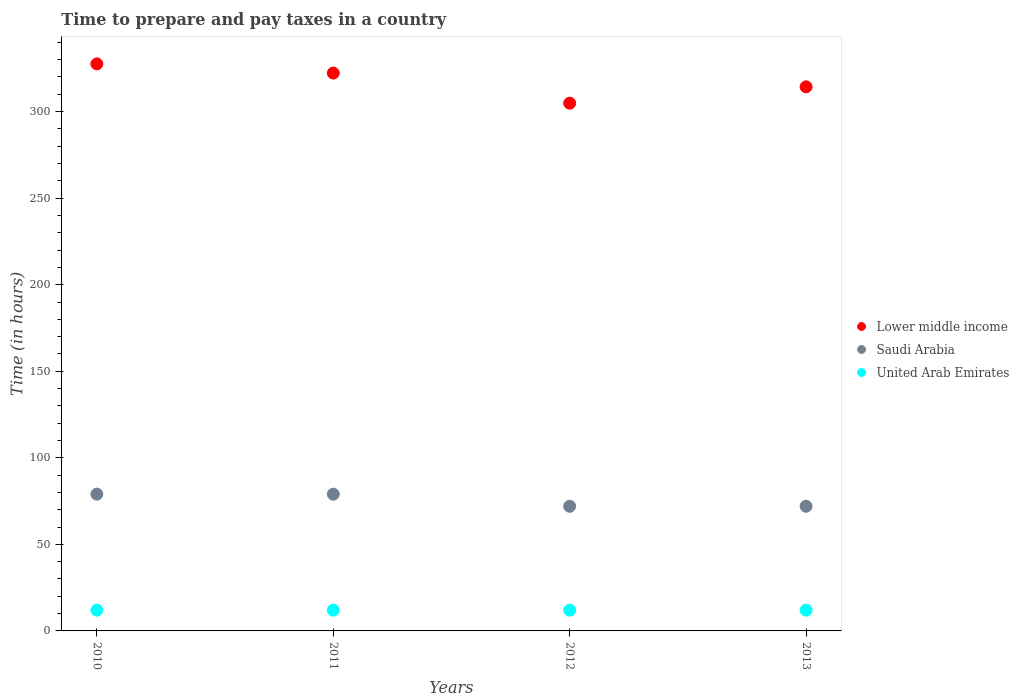What is the number of hours required to prepare and pay taxes in Lower middle income in 2012?
Keep it short and to the point. 304.86. Across all years, what is the maximum number of hours required to prepare and pay taxes in United Arab Emirates?
Provide a succinct answer. 12. Across all years, what is the minimum number of hours required to prepare and pay taxes in United Arab Emirates?
Give a very brief answer. 12. What is the total number of hours required to prepare and pay taxes in Lower middle income in the graph?
Make the answer very short. 1268.98. What is the difference between the number of hours required to prepare and pay taxes in United Arab Emirates in 2011 and that in 2013?
Your answer should be compact. 0. What is the difference between the number of hours required to prepare and pay taxes in Lower middle income in 2013 and the number of hours required to prepare and pay taxes in Saudi Arabia in 2010?
Offer a terse response. 235.31. What is the average number of hours required to prepare and pay taxes in Lower middle income per year?
Give a very brief answer. 317.24. In the year 2010, what is the difference between the number of hours required to prepare and pay taxes in Lower middle income and number of hours required to prepare and pay taxes in United Arab Emirates?
Keep it short and to the point. 315.56. In how many years, is the number of hours required to prepare and pay taxes in United Arab Emirates greater than 190 hours?
Offer a terse response. 0. Is the number of hours required to prepare and pay taxes in United Arab Emirates in 2010 less than that in 2011?
Provide a short and direct response. No. What is the difference between the highest and the second highest number of hours required to prepare and pay taxes in Lower middle income?
Offer a very short reply. 5.32. What is the difference between the highest and the lowest number of hours required to prepare and pay taxes in Saudi Arabia?
Your response must be concise. 7. In how many years, is the number of hours required to prepare and pay taxes in United Arab Emirates greater than the average number of hours required to prepare and pay taxes in United Arab Emirates taken over all years?
Make the answer very short. 0. Is the sum of the number of hours required to prepare and pay taxes in Lower middle income in 2010 and 2011 greater than the maximum number of hours required to prepare and pay taxes in United Arab Emirates across all years?
Provide a short and direct response. Yes. Is it the case that in every year, the sum of the number of hours required to prepare and pay taxes in United Arab Emirates and number of hours required to prepare and pay taxes in Lower middle income  is greater than the number of hours required to prepare and pay taxes in Saudi Arabia?
Provide a short and direct response. Yes. Does the number of hours required to prepare and pay taxes in Lower middle income monotonically increase over the years?
Offer a very short reply. No. Is the number of hours required to prepare and pay taxes in United Arab Emirates strictly greater than the number of hours required to prepare and pay taxes in Lower middle income over the years?
Offer a terse response. No. Is the number of hours required to prepare and pay taxes in Saudi Arabia strictly less than the number of hours required to prepare and pay taxes in United Arab Emirates over the years?
Your answer should be compact. No. What is the difference between two consecutive major ticks on the Y-axis?
Your response must be concise. 50. Does the graph contain grids?
Offer a terse response. No. Where does the legend appear in the graph?
Give a very brief answer. Center right. How many legend labels are there?
Provide a succinct answer. 3. How are the legend labels stacked?
Make the answer very short. Vertical. What is the title of the graph?
Provide a short and direct response. Time to prepare and pay taxes in a country. Does "Sub-Saharan Africa (developing only)" appear as one of the legend labels in the graph?
Give a very brief answer. No. What is the label or title of the Y-axis?
Offer a terse response. Time (in hours). What is the Time (in hours) of Lower middle income in 2010?
Your answer should be compact. 327.56. What is the Time (in hours) of Saudi Arabia in 2010?
Ensure brevity in your answer.  79. What is the Time (in hours) of United Arab Emirates in 2010?
Offer a terse response. 12. What is the Time (in hours) in Lower middle income in 2011?
Give a very brief answer. 322.24. What is the Time (in hours) of Saudi Arabia in 2011?
Your answer should be very brief. 79. What is the Time (in hours) of Lower middle income in 2012?
Provide a short and direct response. 304.86. What is the Time (in hours) in Lower middle income in 2013?
Make the answer very short. 314.31. Across all years, what is the maximum Time (in hours) in Lower middle income?
Provide a succinct answer. 327.56. Across all years, what is the maximum Time (in hours) of Saudi Arabia?
Make the answer very short. 79. Across all years, what is the maximum Time (in hours) of United Arab Emirates?
Ensure brevity in your answer.  12. Across all years, what is the minimum Time (in hours) of Lower middle income?
Offer a very short reply. 304.86. Across all years, what is the minimum Time (in hours) of United Arab Emirates?
Your response must be concise. 12. What is the total Time (in hours) in Lower middle income in the graph?
Give a very brief answer. 1268.98. What is the total Time (in hours) in Saudi Arabia in the graph?
Ensure brevity in your answer.  302. What is the total Time (in hours) of United Arab Emirates in the graph?
Provide a succinct answer. 48. What is the difference between the Time (in hours) in Lower middle income in 2010 and that in 2011?
Your response must be concise. 5.32. What is the difference between the Time (in hours) of Saudi Arabia in 2010 and that in 2011?
Your answer should be very brief. 0. What is the difference between the Time (in hours) in United Arab Emirates in 2010 and that in 2011?
Provide a short and direct response. 0. What is the difference between the Time (in hours) in Lower middle income in 2010 and that in 2012?
Your answer should be compact. 22.7. What is the difference between the Time (in hours) of United Arab Emirates in 2010 and that in 2012?
Ensure brevity in your answer.  0. What is the difference between the Time (in hours) of Lower middle income in 2010 and that in 2013?
Provide a succinct answer. 13.25. What is the difference between the Time (in hours) of Saudi Arabia in 2010 and that in 2013?
Offer a very short reply. 7. What is the difference between the Time (in hours) in Lower middle income in 2011 and that in 2012?
Ensure brevity in your answer.  17.39. What is the difference between the Time (in hours) in Saudi Arabia in 2011 and that in 2012?
Offer a terse response. 7. What is the difference between the Time (in hours) in United Arab Emirates in 2011 and that in 2012?
Provide a succinct answer. 0. What is the difference between the Time (in hours) in Lower middle income in 2011 and that in 2013?
Provide a short and direct response. 7.93. What is the difference between the Time (in hours) of Saudi Arabia in 2011 and that in 2013?
Your response must be concise. 7. What is the difference between the Time (in hours) of United Arab Emirates in 2011 and that in 2013?
Offer a terse response. 0. What is the difference between the Time (in hours) in Lower middle income in 2012 and that in 2013?
Provide a succinct answer. -9.45. What is the difference between the Time (in hours) in United Arab Emirates in 2012 and that in 2013?
Give a very brief answer. 0. What is the difference between the Time (in hours) of Lower middle income in 2010 and the Time (in hours) of Saudi Arabia in 2011?
Give a very brief answer. 248.56. What is the difference between the Time (in hours) in Lower middle income in 2010 and the Time (in hours) in United Arab Emirates in 2011?
Make the answer very short. 315.56. What is the difference between the Time (in hours) in Lower middle income in 2010 and the Time (in hours) in Saudi Arabia in 2012?
Offer a very short reply. 255.56. What is the difference between the Time (in hours) of Lower middle income in 2010 and the Time (in hours) of United Arab Emirates in 2012?
Keep it short and to the point. 315.56. What is the difference between the Time (in hours) in Lower middle income in 2010 and the Time (in hours) in Saudi Arabia in 2013?
Offer a terse response. 255.56. What is the difference between the Time (in hours) of Lower middle income in 2010 and the Time (in hours) of United Arab Emirates in 2013?
Offer a very short reply. 315.56. What is the difference between the Time (in hours) of Saudi Arabia in 2010 and the Time (in hours) of United Arab Emirates in 2013?
Your response must be concise. 67. What is the difference between the Time (in hours) in Lower middle income in 2011 and the Time (in hours) in Saudi Arabia in 2012?
Provide a short and direct response. 250.24. What is the difference between the Time (in hours) in Lower middle income in 2011 and the Time (in hours) in United Arab Emirates in 2012?
Your response must be concise. 310.24. What is the difference between the Time (in hours) of Lower middle income in 2011 and the Time (in hours) of Saudi Arabia in 2013?
Give a very brief answer. 250.24. What is the difference between the Time (in hours) in Lower middle income in 2011 and the Time (in hours) in United Arab Emirates in 2013?
Offer a very short reply. 310.24. What is the difference between the Time (in hours) in Saudi Arabia in 2011 and the Time (in hours) in United Arab Emirates in 2013?
Ensure brevity in your answer.  67. What is the difference between the Time (in hours) in Lower middle income in 2012 and the Time (in hours) in Saudi Arabia in 2013?
Keep it short and to the point. 232.86. What is the difference between the Time (in hours) in Lower middle income in 2012 and the Time (in hours) in United Arab Emirates in 2013?
Offer a very short reply. 292.86. What is the difference between the Time (in hours) of Saudi Arabia in 2012 and the Time (in hours) of United Arab Emirates in 2013?
Make the answer very short. 60. What is the average Time (in hours) of Lower middle income per year?
Your response must be concise. 317.24. What is the average Time (in hours) in Saudi Arabia per year?
Your response must be concise. 75.5. In the year 2010, what is the difference between the Time (in hours) of Lower middle income and Time (in hours) of Saudi Arabia?
Give a very brief answer. 248.56. In the year 2010, what is the difference between the Time (in hours) in Lower middle income and Time (in hours) in United Arab Emirates?
Your answer should be compact. 315.56. In the year 2011, what is the difference between the Time (in hours) in Lower middle income and Time (in hours) in Saudi Arabia?
Offer a terse response. 243.24. In the year 2011, what is the difference between the Time (in hours) of Lower middle income and Time (in hours) of United Arab Emirates?
Your answer should be very brief. 310.24. In the year 2012, what is the difference between the Time (in hours) in Lower middle income and Time (in hours) in Saudi Arabia?
Your response must be concise. 232.86. In the year 2012, what is the difference between the Time (in hours) in Lower middle income and Time (in hours) in United Arab Emirates?
Provide a succinct answer. 292.86. In the year 2012, what is the difference between the Time (in hours) in Saudi Arabia and Time (in hours) in United Arab Emirates?
Ensure brevity in your answer.  60. In the year 2013, what is the difference between the Time (in hours) of Lower middle income and Time (in hours) of Saudi Arabia?
Your answer should be compact. 242.31. In the year 2013, what is the difference between the Time (in hours) in Lower middle income and Time (in hours) in United Arab Emirates?
Your response must be concise. 302.31. In the year 2013, what is the difference between the Time (in hours) in Saudi Arabia and Time (in hours) in United Arab Emirates?
Your answer should be very brief. 60. What is the ratio of the Time (in hours) in Lower middle income in 2010 to that in 2011?
Provide a succinct answer. 1.02. What is the ratio of the Time (in hours) of United Arab Emirates in 2010 to that in 2011?
Give a very brief answer. 1. What is the ratio of the Time (in hours) in Lower middle income in 2010 to that in 2012?
Offer a terse response. 1.07. What is the ratio of the Time (in hours) of Saudi Arabia in 2010 to that in 2012?
Offer a terse response. 1.1. What is the ratio of the Time (in hours) in United Arab Emirates in 2010 to that in 2012?
Give a very brief answer. 1. What is the ratio of the Time (in hours) of Lower middle income in 2010 to that in 2013?
Ensure brevity in your answer.  1.04. What is the ratio of the Time (in hours) of Saudi Arabia in 2010 to that in 2013?
Make the answer very short. 1.1. What is the ratio of the Time (in hours) in United Arab Emirates in 2010 to that in 2013?
Offer a very short reply. 1. What is the ratio of the Time (in hours) of Lower middle income in 2011 to that in 2012?
Your response must be concise. 1.06. What is the ratio of the Time (in hours) of Saudi Arabia in 2011 to that in 2012?
Give a very brief answer. 1.1. What is the ratio of the Time (in hours) in Lower middle income in 2011 to that in 2013?
Make the answer very short. 1.03. What is the ratio of the Time (in hours) in Saudi Arabia in 2011 to that in 2013?
Provide a succinct answer. 1.1. What is the ratio of the Time (in hours) of Lower middle income in 2012 to that in 2013?
Make the answer very short. 0.97. What is the difference between the highest and the second highest Time (in hours) of Lower middle income?
Offer a very short reply. 5.32. What is the difference between the highest and the second highest Time (in hours) of Saudi Arabia?
Make the answer very short. 0. What is the difference between the highest and the second highest Time (in hours) in United Arab Emirates?
Provide a succinct answer. 0. What is the difference between the highest and the lowest Time (in hours) of Lower middle income?
Your response must be concise. 22.7. What is the difference between the highest and the lowest Time (in hours) in United Arab Emirates?
Offer a very short reply. 0. 